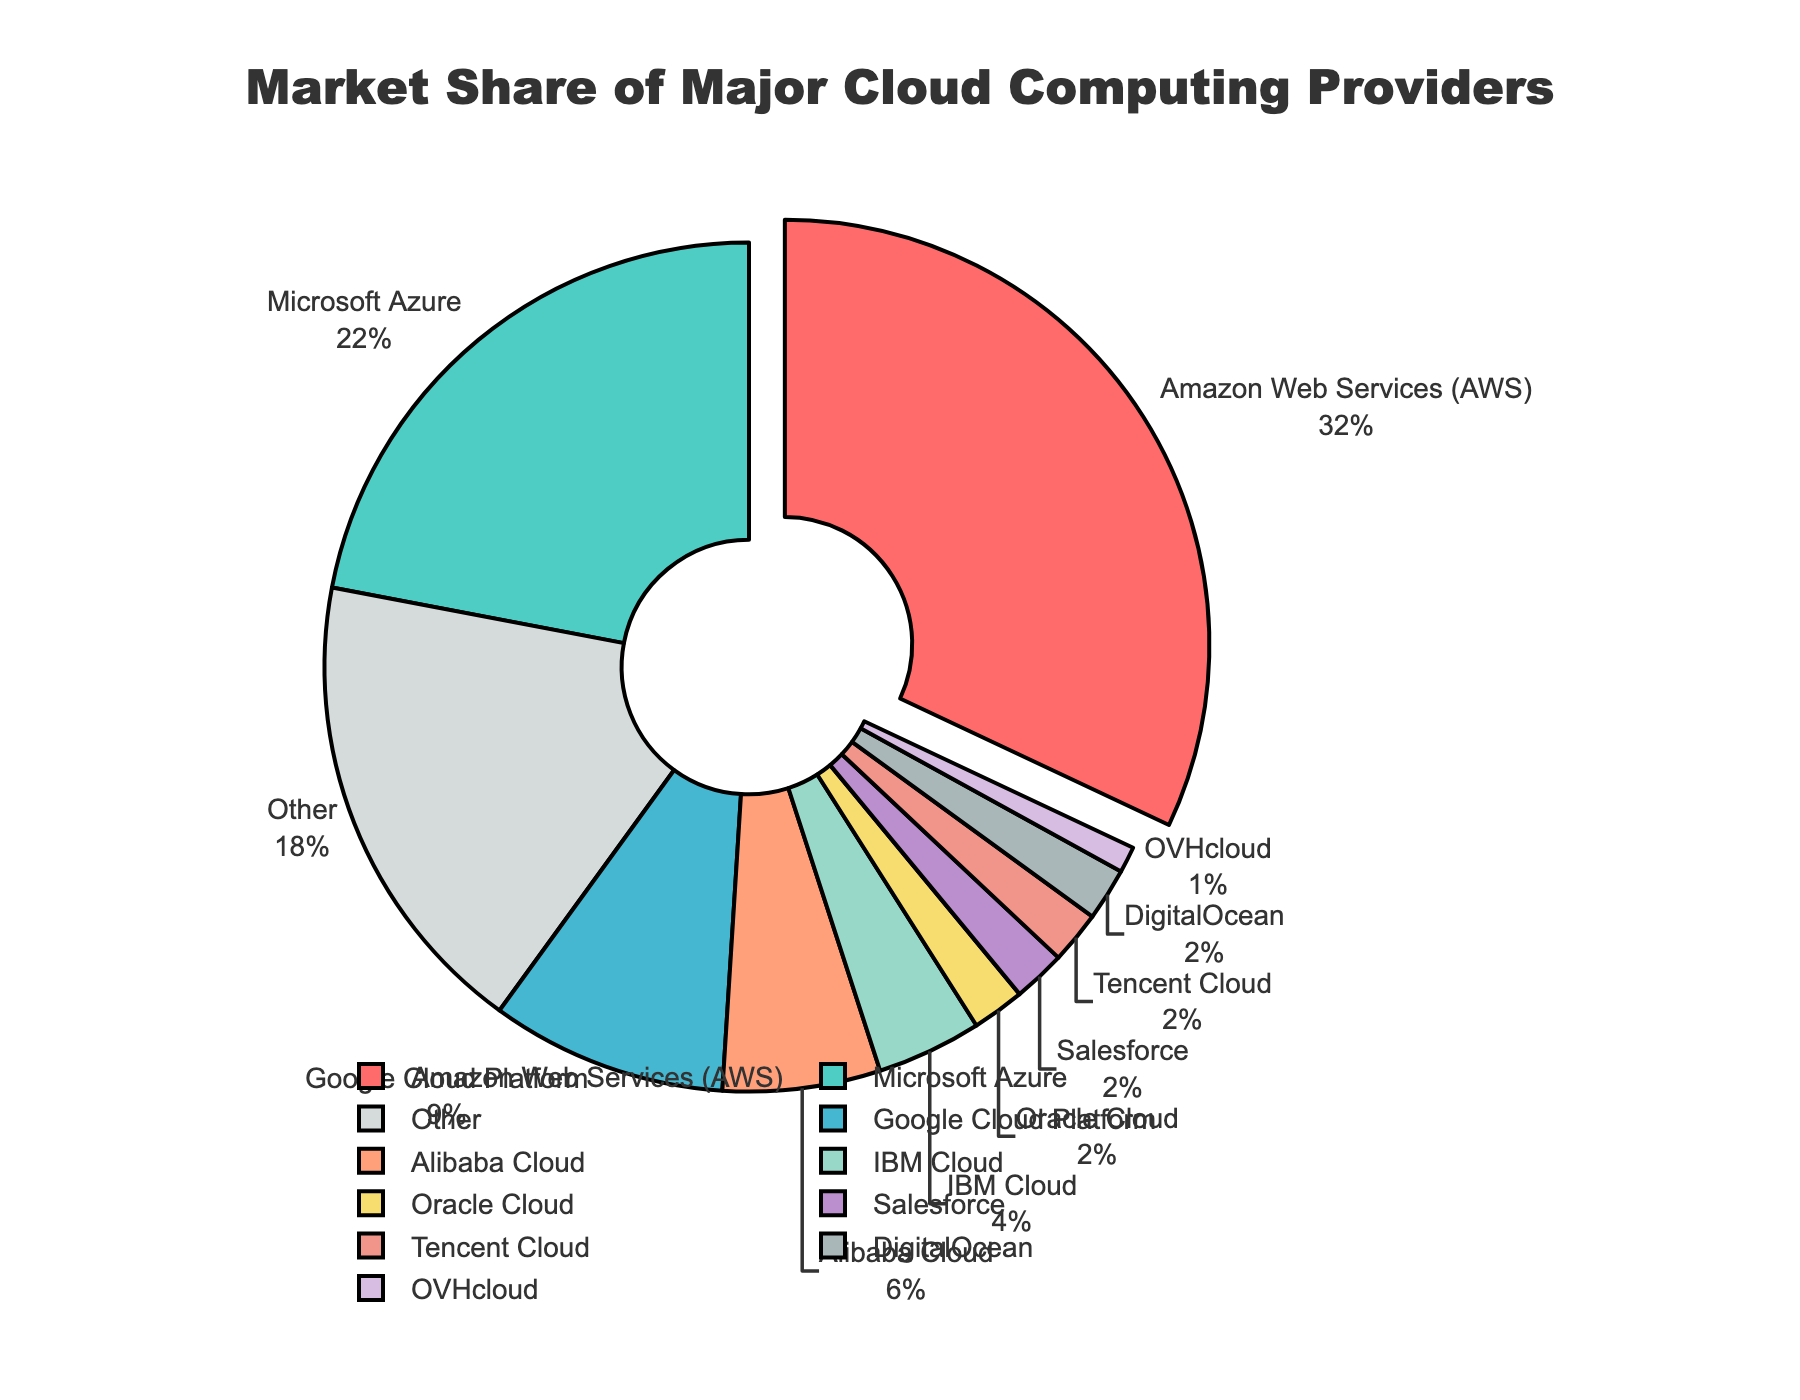What is the largest market share among the cloud computing providers? The largest market share can be identified by looking at the slice pulled out of the pie chart, which represents the provider with the highest percentage. According to the chart, Amazon Web Services (AWS) has the largest market share at 32%.
Answer: Amazon Web Services (AWS) How much greater is AWS's market share compared to Google's? To find the difference in market share between AWS and Google Cloud Platform, subtract Google's market share from AWS's. AWS has 32% and Google Cloud Platform has 9%, so 32% - 9% = 23%.
Answer: 23% What is the combined market share of Oracle Cloud, Salesforce, and Tencent Cloud? Add the market shares of Oracle Cloud (2%), Salesforce (2%), and Tencent Cloud (2%). The combined market share is 2% + 2% + 2% = 6%.
Answer: 6% Which provider has the smallest market share in the chart? The smallest market share can be identified by finding the smallest slice of the pie chart, which belongs to OVHcloud with 1%.
Answer: OVHcloud Are there more providers with a market share of 2% or less than those with more than 6%? Count the providers with 2% or less (Oracle, Salesforce, Tencent, DigitalOcean, OVHcloud) and those with more than 6% (AWS, Microsoft Azure, Google, Alibaba Cloud). There are 5 providers with 2% or less, and 4 providers with more than 6%.
Answer: Yes What percentage of the market is held by providers other than AWS, Microsoft Azure, and Google Cloud Platform? Sum the market shares of AWS (32%), Microsoft Azure (22%), and Google Cloud Platform (9%), and subtract this from 100%. The combined share is 32% + 22% + 9% = 63%. So, 100% - 63% = 37%.
Answer: 37% Which sectors of the pie chart are shaded similarly, and what are their market shares? Similar shadings can be identified by looking at the color similarities. The sectors that have shades of purple are IBM Cloud (4%) and Oracle Cloud (2%), with market shares totaling 6%.
Answer: IBM Cloud and Oracle Cloud, 6% By what factor is AWS’s market share larger than IBM Cloud's market share? To determine the factor, divide AWS's market share by IBM Cloud's market share. AWS has 32% and IBM Cloud has 4%, so 32% / 4% = 8.
Answer: 8 Identify the providers that together make up exactly 10% of the market share. Look for combinations of providers whose market shares sum up to 10%. Oracle Cloud (2%) + Salesforce (2%) + Tencent Cloud (2%) + DigitalOcean (2%) + OVHcloud (1%) + IBM Cloud (1%) = 10%.
Answer: Oracle Cloud, Salesforce, Tencent Cloud, DigitalOcean, OVHcloud, IBM Cloud Does AWS hold more than a third of the total market share? A third of the total market share is 100% / 3 ≈ 33.33%. AWS has a market share of 32%, which is less than 33.33%.
Answer: No 